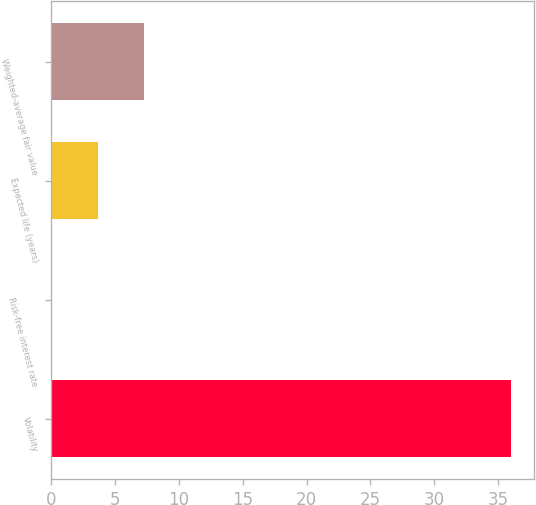<chart> <loc_0><loc_0><loc_500><loc_500><bar_chart><fcel>Volatility<fcel>Risk-free interest rate<fcel>Expected life (years)<fcel>Weighted-average fair value<nl><fcel>36<fcel>0.1<fcel>3.69<fcel>7.28<nl></chart> 